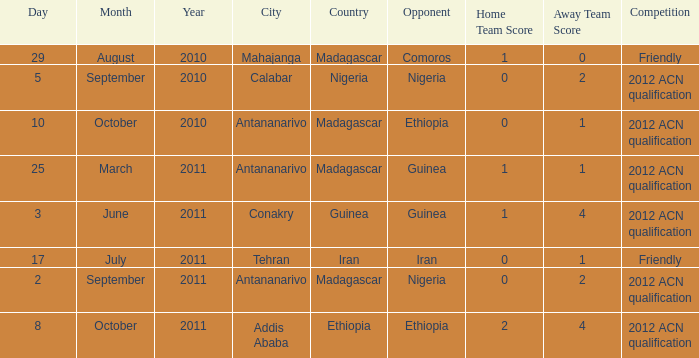Which competition was held at Addis Ababa? 2012 ACN qualification. 